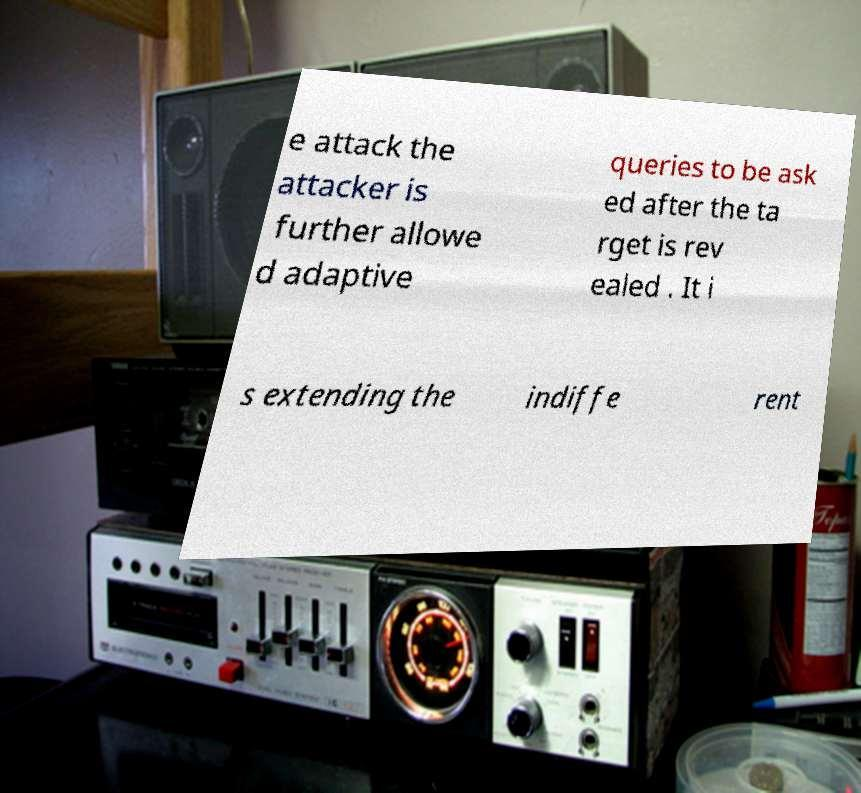Can you accurately transcribe the text from the provided image for me? e attack the attacker is further allowe d adaptive queries to be ask ed after the ta rget is rev ealed . It i s extending the indiffe rent 